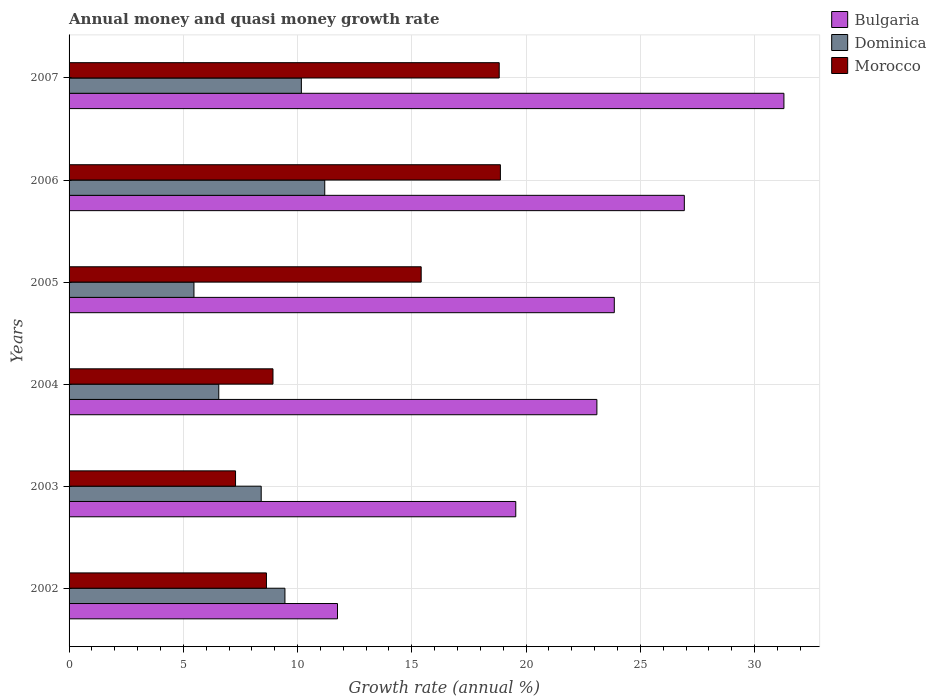How many different coloured bars are there?
Make the answer very short. 3. How many groups of bars are there?
Offer a terse response. 6. How many bars are there on the 3rd tick from the top?
Offer a very short reply. 3. In how many cases, is the number of bars for a given year not equal to the number of legend labels?
Provide a succinct answer. 0. What is the growth rate in Morocco in 2003?
Ensure brevity in your answer.  7.29. Across all years, what is the maximum growth rate in Bulgaria?
Keep it short and to the point. 31.29. Across all years, what is the minimum growth rate in Dominica?
Ensure brevity in your answer.  5.47. In which year was the growth rate in Dominica maximum?
Offer a very short reply. 2006. What is the total growth rate in Bulgaria in the graph?
Make the answer very short. 136.47. What is the difference between the growth rate in Morocco in 2003 and that in 2007?
Offer a terse response. -11.54. What is the difference between the growth rate in Bulgaria in 2004 and the growth rate in Dominica in 2007?
Your answer should be very brief. 12.93. What is the average growth rate in Bulgaria per year?
Your response must be concise. 22.75. In the year 2003, what is the difference between the growth rate in Dominica and growth rate in Morocco?
Ensure brevity in your answer.  1.12. What is the ratio of the growth rate in Morocco in 2005 to that in 2007?
Provide a succinct answer. 0.82. What is the difference between the highest and the second highest growth rate in Dominica?
Ensure brevity in your answer.  1.02. What is the difference between the highest and the lowest growth rate in Morocco?
Your answer should be compact. 11.59. In how many years, is the growth rate in Bulgaria greater than the average growth rate in Bulgaria taken over all years?
Your answer should be very brief. 4. What does the 2nd bar from the top in 2003 represents?
Your answer should be compact. Dominica. What does the 2nd bar from the bottom in 2004 represents?
Your response must be concise. Dominica. Is it the case that in every year, the sum of the growth rate in Morocco and growth rate in Bulgaria is greater than the growth rate in Dominica?
Your answer should be very brief. Yes. How many years are there in the graph?
Your answer should be compact. 6. Are the values on the major ticks of X-axis written in scientific E-notation?
Your answer should be very brief. No. Does the graph contain any zero values?
Ensure brevity in your answer.  No. Does the graph contain grids?
Keep it short and to the point. Yes. Where does the legend appear in the graph?
Your answer should be very brief. Top right. What is the title of the graph?
Your answer should be compact. Annual money and quasi money growth rate. Does "Djibouti" appear as one of the legend labels in the graph?
Provide a short and direct response. No. What is the label or title of the X-axis?
Make the answer very short. Growth rate (annual %). What is the label or title of the Y-axis?
Offer a very short reply. Years. What is the Growth rate (annual %) in Bulgaria in 2002?
Give a very brief answer. 11.75. What is the Growth rate (annual %) of Dominica in 2002?
Make the answer very short. 9.45. What is the Growth rate (annual %) in Morocco in 2002?
Give a very brief answer. 8.64. What is the Growth rate (annual %) of Bulgaria in 2003?
Your answer should be compact. 19.55. What is the Growth rate (annual %) in Dominica in 2003?
Your response must be concise. 8.41. What is the Growth rate (annual %) of Morocco in 2003?
Offer a terse response. 7.29. What is the Growth rate (annual %) in Bulgaria in 2004?
Offer a terse response. 23.1. What is the Growth rate (annual %) in Dominica in 2004?
Your answer should be very brief. 6.55. What is the Growth rate (annual %) of Morocco in 2004?
Provide a succinct answer. 8.92. What is the Growth rate (annual %) in Bulgaria in 2005?
Keep it short and to the point. 23.86. What is the Growth rate (annual %) in Dominica in 2005?
Make the answer very short. 5.47. What is the Growth rate (annual %) in Morocco in 2005?
Provide a short and direct response. 15.41. What is the Growth rate (annual %) in Bulgaria in 2006?
Provide a short and direct response. 26.93. What is the Growth rate (annual %) in Dominica in 2006?
Your answer should be compact. 11.19. What is the Growth rate (annual %) of Morocco in 2006?
Ensure brevity in your answer.  18.88. What is the Growth rate (annual %) in Bulgaria in 2007?
Ensure brevity in your answer.  31.29. What is the Growth rate (annual %) of Dominica in 2007?
Your answer should be compact. 10.17. What is the Growth rate (annual %) of Morocco in 2007?
Provide a succinct answer. 18.83. Across all years, what is the maximum Growth rate (annual %) in Bulgaria?
Offer a terse response. 31.29. Across all years, what is the maximum Growth rate (annual %) in Dominica?
Provide a short and direct response. 11.19. Across all years, what is the maximum Growth rate (annual %) in Morocco?
Give a very brief answer. 18.88. Across all years, what is the minimum Growth rate (annual %) in Bulgaria?
Your answer should be very brief. 11.75. Across all years, what is the minimum Growth rate (annual %) in Dominica?
Give a very brief answer. 5.47. Across all years, what is the minimum Growth rate (annual %) in Morocco?
Your response must be concise. 7.29. What is the total Growth rate (annual %) in Bulgaria in the graph?
Give a very brief answer. 136.47. What is the total Growth rate (annual %) of Dominica in the graph?
Your answer should be compact. 51.23. What is the total Growth rate (annual %) of Morocco in the graph?
Your answer should be very brief. 77.96. What is the difference between the Growth rate (annual %) in Bulgaria in 2002 and that in 2003?
Your response must be concise. -7.8. What is the difference between the Growth rate (annual %) of Dominica in 2002 and that in 2003?
Your answer should be very brief. 1.04. What is the difference between the Growth rate (annual %) of Morocco in 2002 and that in 2003?
Provide a short and direct response. 1.35. What is the difference between the Growth rate (annual %) of Bulgaria in 2002 and that in 2004?
Provide a short and direct response. -11.35. What is the difference between the Growth rate (annual %) of Dominica in 2002 and that in 2004?
Offer a very short reply. 2.9. What is the difference between the Growth rate (annual %) in Morocco in 2002 and that in 2004?
Offer a terse response. -0.29. What is the difference between the Growth rate (annual %) of Bulgaria in 2002 and that in 2005?
Offer a terse response. -12.11. What is the difference between the Growth rate (annual %) of Dominica in 2002 and that in 2005?
Offer a terse response. 3.98. What is the difference between the Growth rate (annual %) in Morocco in 2002 and that in 2005?
Ensure brevity in your answer.  -6.77. What is the difference between the Growth rate (annual %) in Bulgaria in 2002 and that in 2006?
Provide a succinct answer. -15.18. What is the difference between the Growth rate (annual %) of Dominica in 2002 and that in 2006?
Offer a terse response. -1.74. What is the difference between the Growth rate (annual %) of Morocco in 2002 and that in 2006?
Your answer should be very brief. -10.24. What is the difference between the Growth rate (annual %) in Bulgaria in 2002 and that in 2007?
Your response must be concise. -19.54. What is the difference between the Growth rate (annual %) in Dominica in 2002 and that in 2007?
Your answer should be very brief. -0.72. What is the difference between the Growth rate (annual %) in Morocco in 2002 and that in 2007?
Your answer should be compact. -10.19. What is the difference between the Growth rate (annual %) in Bulgaria in 2003 and that in 2004?
Give a very brief answer. -3.55. What is the difference between the Growth rate (annual %) of Dominica in 2003 and that in 2004?
Make the answer very short. 1.86. What is the difference between the Growth rate (annual %) of Morocco in 2003 and that in 2004?
Offer a terse response. -1.64. What is the difference between the Growth rate (annual %) in Bulgaria in 2003 and that in 2005?
Your answer should be very brief. -4.31. What is the difference between the Growth rate (annual %) of Dominica in 2003 and that in 2005?
Your response must be concise. 2.94. What is the difference between the Growth rate (annual %) in Morocco in 2003 and that in 2005?
Offer a very short reply. -8.12. What is the difference between the Growth rate (annual %) of Bulgaria in 2003 and that in 2006?
Keep it short and to the point. -7.38. What is the difference between the Growth rate (annual %) of Dominica in 2003 and that in 2006?
Keep it short and to the point. -2.78. What is the difference between the Growth rate (annual %) in Morocco in 2003 and that in 2006?
Your response must be concise. -11.59. What is the difference between the Growth rate (annual %) in Bulgaria in 2003 and that in 2007?
Give a very brief answer. -11.74. What is the difference between the Growth rate (annual %) of Dominica in 2003 and that in 2007?
Your response must be concise. -1.76. What is the difference between the Growth rate (annual %) in Morocco in 2003 and that in 2007?
Offer a terse response. -11.54. What is the difference between the Growth rate (annual %) of Bulgaria in 2004 and that in 2005?
Make the answer very short. -0.76. What is the difference between the Growth rate (annual %) of Dominica in 2004 and that in 2005?
Give a very brief answer. 1.09. What is the difference between the Growth rate (annual %) of Morocco in 2004 and that in 2005?
Your answer should be compact. -6.49. What is the difference between the Growth rate (annual %) of Bulgaria in 2004 and that in 2006?
Offer a very short reply. -3.83. What is the difference between the Growth rate (annual %) in Dominica in 2004 and that in 2006?
Make the answer very short. -4.64. What is the difference between the Growth rate (annual %) in Morocco in 2004 and that in 2006?
Keep it short and to the point. -9.95. What is the difference between the Growth rate (annual %) of Bulgaria in 2004 and that in 2007?
Provide a short and direct response. -8.19. What is the difference between the Growth rate (annual %) in Dominica in 2004 and that in 2007?
Your answer should be very brief. -3.62. What is the difference between the Growth rate (annual %) of Morocco in 2004 and that in 2007?
Provide a succinct answer. -9.9. What is the difference between the Growth rate (annual %) in Bulgaria in 2005 and that in 2006?
Offer a very short reply. -3.07. What is the difference between the Growth rate (annual %) in Dominica in 2005 and that in 2006?
Make the answer very short. -5.72. What is the difference between the Growth rate (annual %) of Morocco in 2005 and that in 2006?
Give a very brief answer. -3.47. What is the difference between the Growth rate (annual %) of Bulgaria in 2005 and that in 2007?
Your response must be concise. -7.42. What is the difference between the Growth rate (annual %) of Dominica in 2005 and that in 2007?
Keep it short and to the point. -4.7. What is the difference between the Growth rate (annual %) in Morocco in 2005 and that in 2007?
Keep it short and to the point. -3.41. What is the difference between the Growth rate (annual %) in Bulgaria in 2006 and that in 2007?
Ensure brevity in your answer.  -4.36. What is the difference between the Growth rate (annual %) of Dominica in 2006 and that in 2007?
Offer a terse response. 1.02. What is the difference between the Growth rate (annual %) of Morocco in 2006 and that in 2007?
Keep it short and to the point. 0.05. What is the difference between the Growth rate (annual %) in Bulgaria in 2002 and the Growth rate (annual %) in Dominica in 2003?
Give a very brief answer. 3.34. What is the difference between the Growth rate (annual %) in Bulgaria in 2002 and the Growth rate (annual %) in Morocco in 2003?
Provide a succinct answer. 4.46. What is the difference between the Growth rate (annual %) of Dominica in 2002 and the Growth rate (annual %) of Morocco in 2003?
Give a very brief answer. 2.16. What is the difference between the Growth rate (annual %) of Bulgaria in 2002 and the Growth rate (annual %) of Dominica in 2004?
Make the answer very short. 5.2. What is the difference between the Growth rate (annual %) of Bulgaria in 2002 and the Growth rate (annual %) of Morocco in 2004?
Your answer should be very brief. 2.82. What is the difference between the Growth rate (annual %) in Dominica in 2002 and the Growth rate (annual %) in Morocco in 2004?
Provide a short and direct response. 0.52. What is the difference between the Growth rate (annual %) of Bulgaria in 2002 and the Growth rate (annual %) of Dominica in 2005?
Your answer should be compact. 6.28. What is the difference between the Growth rate (annual %) in Bulgaria in 2002 and the Growth rate (annual %) in Morocco in 2005?
Your answer should be compact. -3.66. What is the difference between the Growth rate (annual %) in Dominica in 2002 and the Growth rate (annual %) in Morocco in 2005?
Your response must be concise. -5.96. What is the difference between the Growth rate (annual %) of Bulgaria in 2002 and the Growth rate (annual %) of Dominica in 2006?
Ensure brevity in your answer.  0.56. What is the difference between the Growth rate (annual %) in Bulgaria in 2002 and the Growth rate (annual %) in Morocco in 2006?
Your answer should be very brief. -7.13. What is the difference between the Growth rate (annual %) in Dominica in 2002 and the Growth rate (annual %) in Morocco in 2006?
Your response must be concise. -9.43. What is the difference between the Growth rate (annual %) of Bulgaria in 2002 and the Growth rate (annual %) of Dominica in 2007?
Your answer should be compact. 1.58. What is the difference between the Growth rate (annual %) of Bulgaria in 2002 and the Growth rate (annual %) of Morocco in 2007?
Ensure brevity in your answer.  -7.08. What is the difference between the Growth rate (annual %) in Dominica in 2002 and the Growth rate (annual %) in Morocco in 2007?
Keep it short and to the point. -9.38. What is the difference between the Growth rate (annual %) in Bulgaria in 2003 and the Growth rate (annual %) in Dominica in 2004?
Your answer should be very brief. 13. What is the difference between the Growth rate (annual %) in Bulgaria in 2003 and the Growth rate (annual %) in Morocco in 2004?
Your answer should be compact. 10.63. What is the difference between the Growth rate (annual %) in Dominica in 2003 and the Growth rate (annual %) in Morocco in 2004?
Offer a terse response. -0.52. What is the difference between the Growth rate (annual %) of Bulgaria in 2003 and the Growth rate (annual %) of Dominica in 2005?
Give a very brief answer. 14.08. What is the difference between the Growth rate (annual %) in Bulgaria in 2003 and the Growth rate (annual %) in Morocco in 2005?
Offer a terse response. 4.14. What is the difference between the Growth rate (annual %) of Dominica in 2003 and the Growth rate (annual %) of Morocco in 2005?
Give a very brief answer. -7. What is the difference between the Growth rate (annual %) of Bulgaria in 2003 and the Growth rate (annual %) of Dominica in 2006?
Your answer should be very brief. 8.36. What is the difference between the Growth rate (annual %) in Bulgaria in 2003 and the Growth rate (annual %) in Morocco in 2006?
Provide a succinct answer. 0.67. What is the difference between the Growth rate (annual %) of Dominica in 2003 and the Growth rate (annual %) of Morocco in 2006?
Keep it short and to the point. -10.47. What is the difference between the Growth rate (annual %) in Bulgaria in 2003 and the Growth rate (annual %) in Dominica in 2007?
Provide a succinct answer. 9.38. What is the difference between the Growth rate (annual %) of Bulgaria in 2003 and the Growth rate (annual %) of Morocco in 2007?
Provide a short and direct response. 0.72. What is the difference between the Growth rate (annual %) in Dominica in 2003 and the Growth rate (annual %) in Morocco in 2007?
Provide a short and direct response. -10.42. What is the difference between the Growth rate (annual %) of Bulgaria in 2004 and the Growth rate (annual %) of Dominica in 2005?
Ensure brevity in your answer.  17.63. What is the difference between the Growth rate (annual %) of Bulgaria in 2004 and the Growth rate (annual %) of Morocco in 2005?
Keep it short and to the point. 7.69. What is the difference between the Growth rate (annual %) of Dominica in 2004 and the Growth rate (annual %) of Morocco in 2005?
Offer a very short reply. -8.86. What is the difference between the Growth rate (annual %) in Bulgaria in 2004 and the Growth rate (annual %) in Dominica in 2006?
Keep it short and to the point. 11.91. What is the difference between the Growth rate (annual %) in Bulgaria in 2004 and the Growth rate (annual %) in Morocco in 2006?
Offer a terse response. 4.22. What is the difference between the Growth rate (annual %) of Dominica in 2004 and the Growth rate (annual %) of Morocco in 2006?
Provide a succinct answer. -12.33. What is the difference between the Growth rate (annual %) of Bulgaria in 2004 and the Growth rate (annual %) of Dominica in 2007?
Ensure brevity in your answer.  12.93. What is the difference between the Growth rate (annual %) in Bulgaria in 2004 and the Growth rate (annual %) in Morocco in 2007?
Your answer should be very brief. 4.28. What is the difference between the Growth rate (annual %) of Dominica in 2004 and the Growth rate (annual %) of Morocco in 2007?
Offer a very short reply. -12.27. What is the difference between the Growth rate (annual %) in Bulgaria in 2005 and the Growth rate (annual %) in Dominica in 2006?
Your answer should be very brief. 12.67. What is the difference between the Growth rate (annual %) in Bulgaria in 2005 and the Growth rate (annual %) in Morocco in 2006?
Your answer should be compact. 4.98. What is the difference between the Growth rate (annual %) in Dominica in 2005 and the Growth rate (annual %) in Morocco in 2006?
Your answer should be very brief. -13.41. What is the difference between the Growth rate (annual %) of Bulgaria in 2005 and the Growth rate (annual %) of Dominica in 2007?
Provide a succinct answer. 13.7. What is the difference between the Growth rate (annual %) in Bulgaria in 2005 and the Growth rate (annual %) in Morocco in 2007?
Make the answer very short. 5.04. What is the difference between the Growth rate (annual %) of Dominica in 2005 and the Growth rate (annual %) of Morocco in 2007?
Keep it short and to the point. -13.36. What is the difference between the Growth rate (annual %) of Bulgaria in 2006 and the Growth rate (annual %) of Dominica in 2007?
Make the answer very short. 16.76. What is the difference between the Growth rate (annual %) in Bulgaria in 2006 and the Growth rate (annual %) in Morocco in 2007?
Ensure brevity in your answer.  8.1. What is the difference between the Growth rate (annual %) of Dominica in 2006 and the Growth rate (annual %) of Morocco in 2007?
Your response must be concise. -7.64. What is the average Growth rate (annual %) in Bulgaria per year?
Make the answer very short. 22.75. What is the average Growth rate (annual %) of Dominica per year?
Ensure brevity in your answer.  8.54. What is the average Growth rate (annual %) of Morocco per year?
Make the answer very short. 12.99. In the year 2002, what is the difference between the Growth rate (annual %) in Bulgaria and Growth rate (annual %) in Dominica?
Give a very brief answer. 2.3. In the year 2002, what is the difference between the Growth rate (annual %) of Bulgaria and Growth rate (annual %) of Morocco?
Provide a short and direct response. 3.11. In the year 2002, what is the difference between the Growth rate (annual %) of Dominica and Growth rate (annual %) of Morocco?
Your answer should be very brief. 0.81. In the year 2003, what is the difference between the Growth rate (annual %) of Bulgaria and Growth rate (annual %) of Dominica?
Provide a short and direct response. 11.14. In the year 2003, what is the difference between the Growth rate (annual %) in Bulgaria and Growth rate (annual %) in Morocco?
Make the answer very short. 12.26. In the year 2003, what is the difference between the Growth rate (annual %) of Dominica and Growth rate (annual %) of Morocco?
Offer a terse response. 1.12. In the year 2004, what is the difference between the Growth rate (annual %) of Bulgaria and Growth rate (annual %) of Dominica?
Ensure brevity in your answer.  16.55. In the year 2004, what is the difference between the Growth rate (annual %) of Bulgaria and Growth rate (annual %) of Morocco?
Your answer should be very brief. 14.18. In the year 2004, what is the difference between the Growth rate (annual %) in Dominica and Growth rate (annual %) in Morocco?
Offer a very short reply. -2.37. In the year 2005, what is the difference between the Growth rate (annual %) of Bulgaria and Growth rate (annual %) of Dominica?
Your answer should be compact. 18.4. In the year 2005, what is the difference between the Growth rate (annual %) of Bulgaria and Growth rate (annual %) of Morocco?
Offer a terse response. 8.45. In the year 2005, what is the difference between the Growth rate (annual %) of Dominica and Growth rate (annual %) of Morocco?
Keep it short and to the point. -9.94. In the year 2006, what is the difference between the Growth rate (annual %) in Bulgaria and Growth rate (annual %) in Dominica?
Offer a very short reply. 15.74. In the year 2006, what is the difference between the Growth rate (annual %) of Bulgaria and Growth rate (annual %) of Morocco?
Provide a succinct answer. 8.05. In the year 2006, what is the difference between the Growth rate (annual %) of Dominica and Growth rate (annual %) of Morocco?
Make the answer very short. -7.69. In the year 2007, what is the difference between the Growth rate (annual %) of Bulgaria and Growth rate (annual %) of Dominica?
Give a very brief answer. 21.12. In the year 2007, what is the difference between the Growth rate (annual %) of Bulgaria and Growth rate (annual %) of Morocco?
Provide a succinct answer. 12.46. In the year 2007, what is the difference between the Growth rate (annual %) of Dominica and Growth rate (annual %) of Morocco?
Offer a very short reply. -8.66. What is the ratio of the Growth rate (annual %) of Bulgaria in 2002 to that in 2003?
Provide a short and direct response. 0.6. What is the ratio of the Growth rate (annual %) of Dominica in 2002 to that in 2003?
Your answer should be compact. 1.12. What is the ratio of the Growth rate (annual %) in Morocco in 2002 to that in 2003?
Offer a very short reply. 1.19. What is the ratio of the Growth rate (annual %) in Bulgaria in 2002 to that in 2004?
Your answer should be very brief. 0.51. What is the ratio of the Growth rate (annual %) of Dominica in 2002 to that in 2004?
Keep it short and to the point. 1.44. What is the ratio of the Growth rate (annual %) of Morocco in 2002 to that in 2004?
Your answer should be compact. 0.97. What is the ratio of the Growth rate (annual %) of Bulgaria in 2002 to that in 2005?
Keep it short and to the point. 0.49. What is the ratio of the Growth rate (annual %) in Dominica in 2002 to that in 2005?
Your response must be concise. 1.73. What is the ratio of the Growth rate (annual %) in Morocco in 2002 to that in 2005?
Offer a terse response. 0.56. What is the ratio of the Growth rate (annual %) in Bulgaria in 2002 to that in 2006?
Keep it short and to the point. 0.44. What is the ratio of the Growth rate (annual %) in Dominica in 2002 to that in 2006?
Ensure brevity in your answer.  0.84. What is the ratio of the Growth rate (annual %) in Morocco in 2002 to that in 2006?
Ensure brevity in your answer.  0.46. What is the ratio of the Growth rate (annual %) of Bulgaria in 2002 to that in 2007?
Your answer should be compact. 0.38. What is the ratio of the Growth rate (annual %) in Dominica in 2002 to that in 2007?
Provide a short and direct response. 0.93. What is the ratio of the Growth rate (annual %) of Morocco in 2002 to that in 2007?
Keep it short and to the point. 0.46. What is the ratio of the Growth rate (annual %) of Bulgaria in 2003 to that in 2004?
Keep it short and to the point. 0.85. What is the ratio of the Growth rate (annual %) of Dominica in 2003 to that in 2004?
Make the answer very short. 1.28. What is the ratio of the Growth rate (annual %) in Morocco in 2003 to that in 2004?
Offer a very short reply. 0.82. What is the ratio of the Growth rate (annual %) of Bulgaria in 2003 to that in 2005?
Offer a very short reply. 0.82. What is the ratio of the Growth rate (annual %) of Dominica in 2003 to that in 2005?
Ensure brevity in your answer.  1.54. What is the ratio of the Growth rate (annual %) of Morocco in 2003 to that in 2005?
Your response must be concise. 0.47. What is the ratio of the Growth rate (annual %) in Bulgaria in 2003 to that in 2006?
Your answer should be very brief. 0.73. What is the ratio of the Growth rate (annual %) of Dominica in 2003 to that in 2006?
Offer a terse response. 0.75. What is the ratio of the Growth rate (annual %) in Morocco in 2003 to that in 2006?
Your response must be concise. 0.39. What is the ratio of the Growth rate (annual %) in Bulgaria in 2003 to that in 2007?
Ensure brevity in your answer.  0.62. What is the ratio of the Growth rate (annual %) of Dominica in 2003 to that in 2007?
Your answer should be compact. 0.83. What is the ratio of the Growth rate (annual %) in Morocco in 2003 to that in 2007?
Keep it short and to the point. 0.39. What is the ratio of the Growth rate (annual %) in Bulgaria in 2004 to that in 2005?
Make the answer very short. 0.97. What is the ratio of the Growth rate (annual %) of Dominica in 2004 to that in 2005?
Offer a very short reply. 1.2. What is the ratio of the Growth rate (annual %) in Morocco in 2004 to that in 2005?
Offer a very short reply. 0.58. What is the ratio of the Growth rate (annual %) in Bulgaria in 2004 to that in 2006?
Your response must be concise. 0.86. What is the ratio of the Growth rate (annual %) in Dominica in 2004 to that in 2006?
Give a very brief answer. 0.59. What is the ratio of the Growth rate (annual %) in Morocco in 2004 to that in 2006?
Provide a succinct answer. 0.47. What is the ratio of the Growth rate (annual %) of Bulgaria in 2004 to that in 2007?
Give a very brief answer. 0.74. What is the ratio of the Growth rate (annual %) of Dominica in 2004 to that in 2007?
Your answer should be compact. 0.64. What is the ratio of the Growth rate (annual %) in Morocco in 2004 to that in 2007?
Offer a very short reply. 0.47. What is the ratio of the Growth rate (annual %) in Bulgaria in 2005 to that in 2006?
Your response must be concise. 0.89. What is the ratio of the Growth rate (annual %) in Dominica in 2005 to that in 2006?
Keep it short and to the point. 0.49. What is the ratio of the Growth rate (annual %) in Morocco in 2005 to that in 2006?
Your answer should be very brief. 0.82. What is the ratio of the Growth rate (annual %) in Bulgaria in 2005 to that in 2007?
Keep it short and to the point. 0.76. What is the ratio of the Growth rate (annual %) of Dominica in 2005 to that in 2007?
Give a very brief answer. 0.54. What is the ratio of the Growth rate (annual %) in Morocco in 2005 to that in 2007?
Provide a succinct answer. 0.82. What is the ratio of the Growth rate (annual %) in Bulgaria in 2006 to that in 2007?
Your answer should be compact. 0.86. What is the ratio of the Growth rate (annual %) in Dominica in 2006 to that in 2007?
Make the answer very short. 1.1. What is the difference between the highest and the second highest Growth rate (annual %) of Bulgaria?
Offer a terse response. 4.36. What is the difference between the highest and the second highest Growth rate (annual %) of Dominica?
Your response must be concise. 1.02. What is the difference between the highest and the second highest Growth rate (annual %) of Morocco?
Your answer should be very brief. 0.05. What is the difference between the highest and the lowest Growth rate (annual %) in Bulgaria?
Provide a succinct answer. 19.54. What is the difference between the highest and the lowest Growth rate (annual %) in Dominica?
Your answer should be very brief. 5.72. What is the difference between the highest and the lowest Growth rate (annual %) in Morocco?
Offer a very short reply. 11.59. 